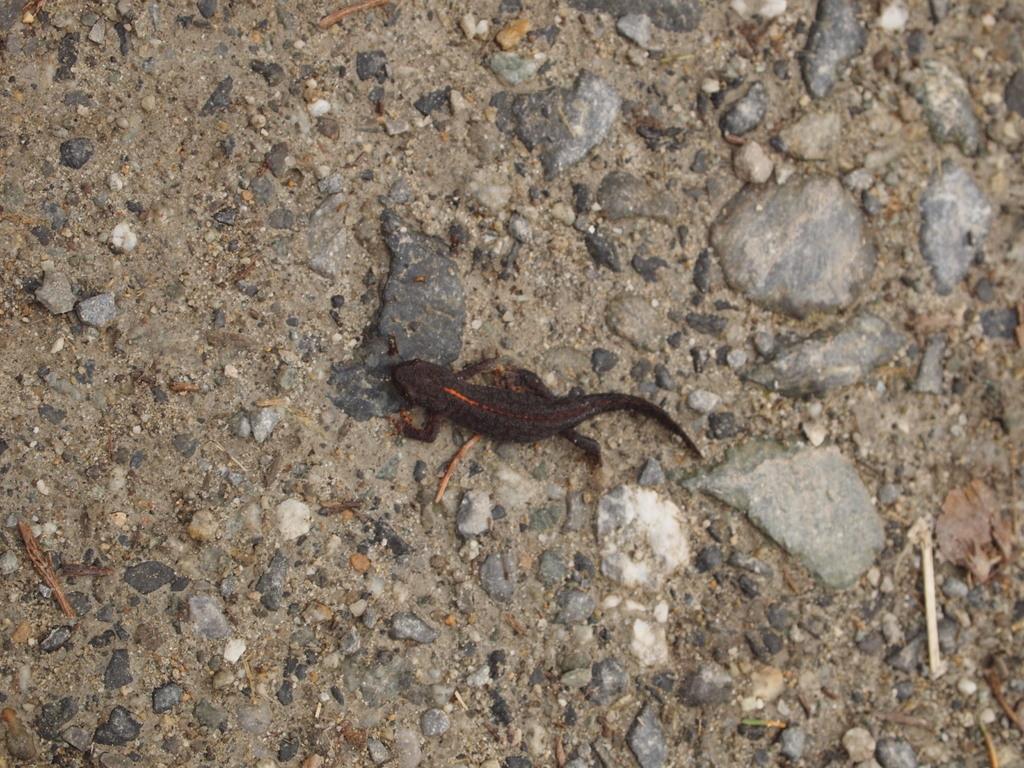Describe this image in one or two sentences. In this picture there is a brown color lizard. At the bottom there is a ground and there are stones. 